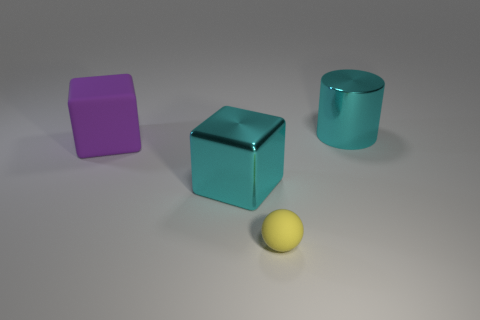There is a block that is the same color as the cylinder; what size is it?
Offer a very short reply. Large. There is another thing that is made of the same material as the big purple thing; what shape is it?
Offer a very short reply. Sphere. Do the purple rubber cube and the yellow sphere have the same size?
Keep it short and to the point. No. Are there fewer cyan cubes on the left side of the small matte object than big cylinders on the left side of the large cyan shiny block?
Your answer should be compact. No. What is the size of the object that is both right of the large purple thing and left of the yellow rubber sphere?
Your answer should be very brief. Large. There is a large cube that is to the left of the cyan object that is in front of the purple thing; is there a big cyan metal thing behind it?
Give a very brief answer. Yes. Are any large purple metallic cubes visible?
Provide a short and direct response. No. Is the number of cubes that are to the left of the purple rubber object greater than the number of large cyan objects on the left side of the big metallic block?
Offer a very short reply. No. There is another purple thing that is the same material as the tiny thing; what is its size?
Your response must be concise. Large. What is the size of the shiny thing on the left side of the cyan metal object that is to the right of the tiny yellow rubber object that is on the right side of the big cyan metallic cube?
Give a very brief answer. Large. 